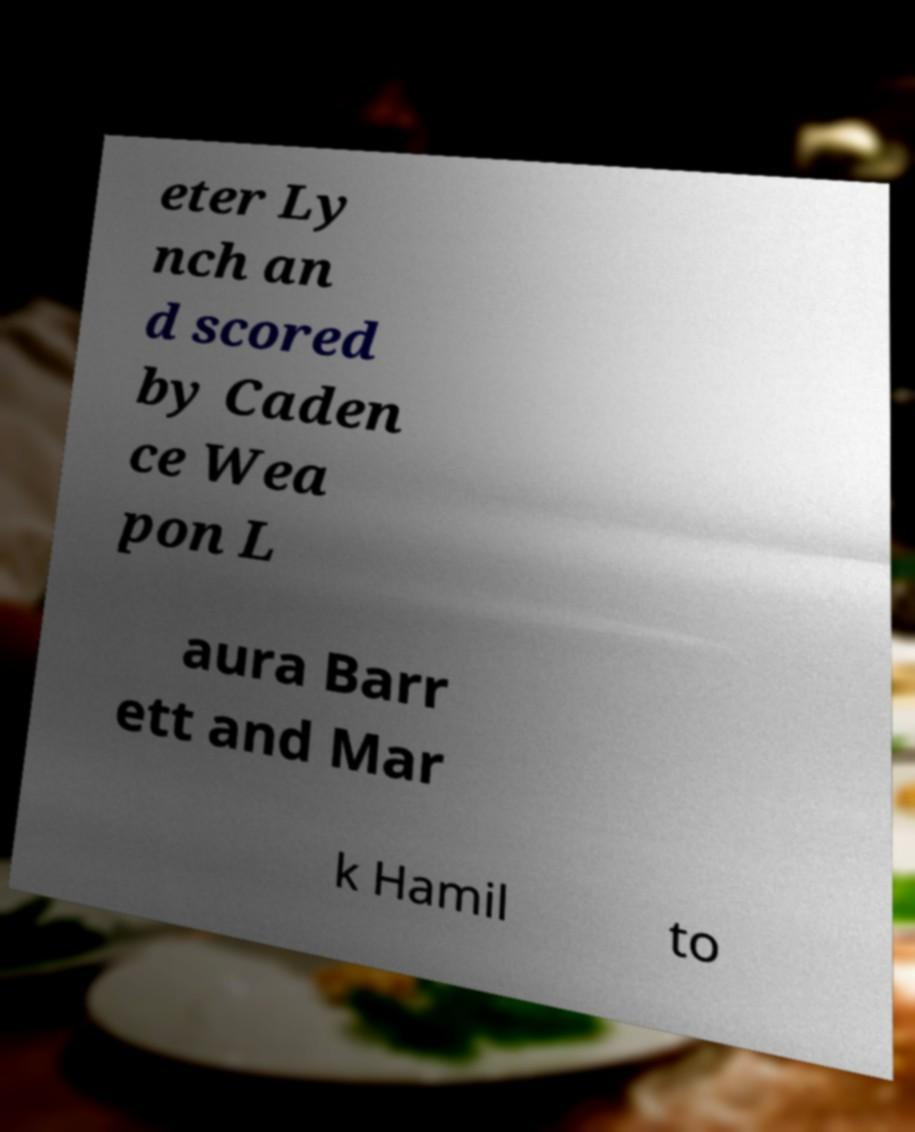Can you accurately transcribe the text from the provided image for me? eter Ly nch an d scored by Caden ce Wea pon L aura Barr ett and Mar k Hamil to 